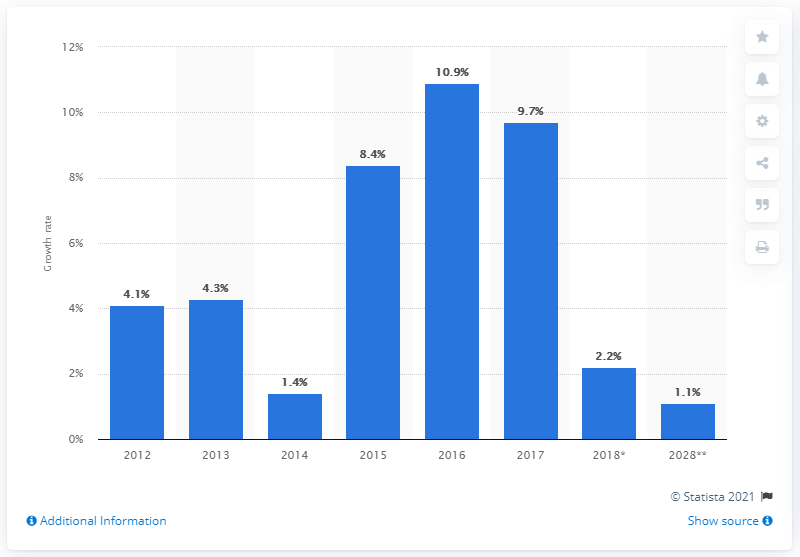Point out several critical features in this image. In 2012, the growth rate of imported goods from indirect spending in the UK was impacted by the travel and tourism industry. 